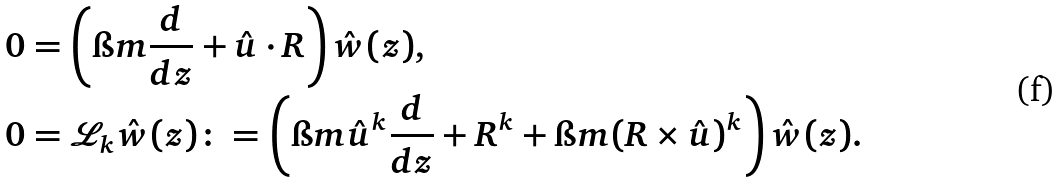Convert formula to latex. <formula><loc_0><loc_0><loc_500><loc_500>0 & = \left ( \i m \frac { d } { d z } + \hat { u } \cdot R \right ) \hat { w } ( z ) , \\ 0 & = \mathcal { L } _ { k } \hat { w } ( z ) \colon = \left ( \i m { \hat { u } } ^ { k } \frac { d } { d z } + R ^ { k } + \i m ( R \times \hat { u } ) ^ { k } \right ) \hat { w } ( z ) .</formula> 